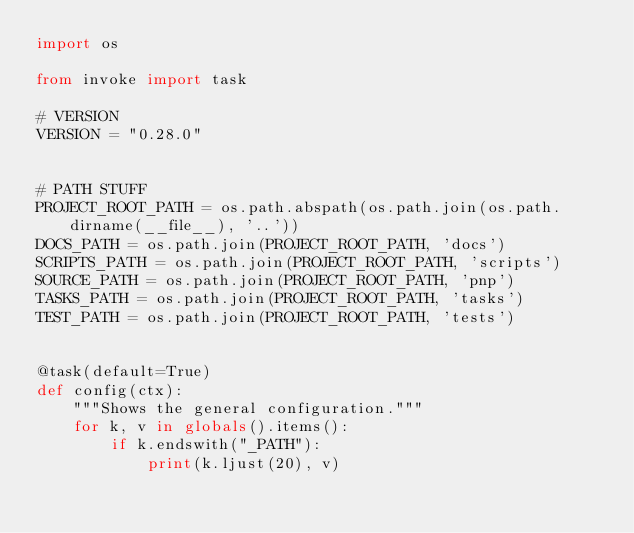Convert code to text. <code><loc_0><loc_0><loc_500><loc_500><_Python_>import os

from invoke import task

# VERSION
VERSION = "0.28.0"


# PATH STUFF
PROJECT_ROOT_PATH = os.path.abspath(os.path.join(os.path.dirname(__file__), '..'))
DOCS_PATH = os.path.join(PROJECT_ROOT_PATH, 'docs')
SCRIPTS_PATH = os.path.join(PROJECT_ROOT_PATH, 'scripts')
SOURCE_PATH = os.path.join(PROJECT_ROOT_PATH, 'pnp')
TASKS_PATH = os.path.join(PROJECT_ROOT_PATH, 'tasks')
TEST_PATH = os.path.join(PROJECT_ROOT_PATH, 'tests')


@task(default=True)
def config(ctx):
    """Shows the general configuration."""
    for k, v in globals().items():
        if k.endswith("_PATH"):
            print(k.ljust(20), v)
</code> 